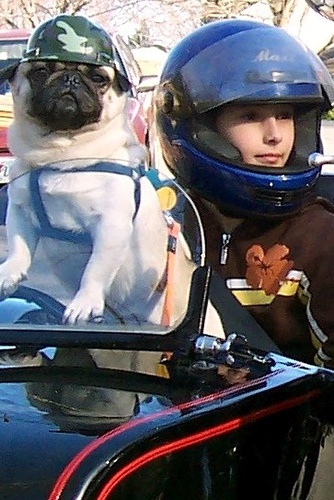Describe the objects in this image and their specific colors. I can see people in tan, black, gray, and maroon tones and dog in tan, lightgray, darkgray, black, and gray tones in this image. 